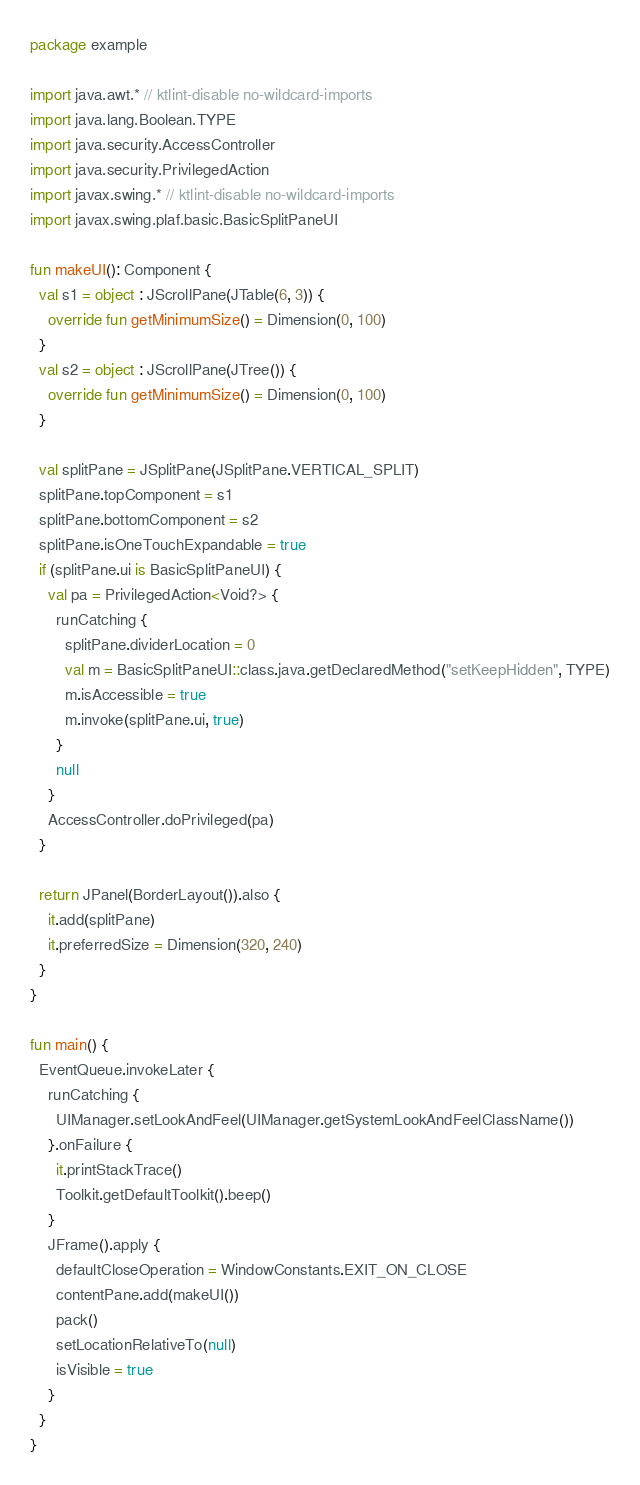Convert code to text. <code><loc_0><loc_0><loc_500><loc_500><_Kotlin_>package example

import java.awt.* // ktlint-disable no-wildcard-imports
import java.lang.Boolean.TYPE
import java.security.AccessController
import java.security.PrivilegedAction
import javax.swing.* // ktlint-disable no-wildcard-imports
import javax.swing.plaf.basic.BasicSplitPaneUI

fun makeUI(): Component {
  val s1 = object : JScrollPane(JTable(6, 3)) {
    override fun getMinimumSize() = Dimension(0, 100)
  }
  val s2 = object : JScrollPane(JTree()) {
    override fun getMinimumSize() = Dimension(0, 100)
  }

  val splitPane = JSplitPane(JSplitPane.VERTICAL_SPLIT)
  splitPane.topComponent = s1
  splitPane.bottomComponent = s2
  splitPane.isOneTouchExpandable = true
  if (splitPane.ui is BasicSplitPaneUI) {
    val pa = PrivilegedAction<Void?> {
      runCatching {
        splitPane.dividerLocation = 0
        val m = BasicSplitPaneUI::class.java.getDeclaredMethod("setKeepHidden", TYPE)
        m.isAccessible = true
        m.invoke(splitPane.ui, true)
      }
      null
    }
    AccessController.doPrivileged(pa)
  }

  return JPanel(BorderLayout()).also {
    it.add(splitPane)
    it.preferredSize = Dimension(320, 240)
  }
}

fun main() {
  EventQueue.invokeLater {
    runCatching {
      UIManager.setLookAndFeel(UIManager.getSystemLookAndFeelClassName())
    }.onFailure {
      it.printStackTrace()
      Toolkit.getDefaultToolkit().beep()
    }
    JFrame().apply {
      defaultCloseOperation = WindowConstants.EXIT_ON_CLOSE
      contentPane.add(makeUI())
      pack()
      setLocationRelativeTo(null)
      isVisible = true
    }
  }
}
</code> 